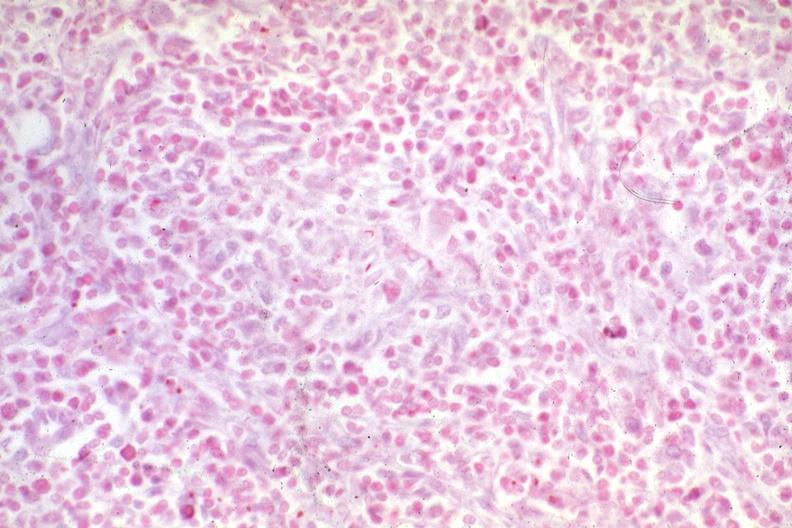what is present?
Answer the question using a single word or phrase. Lymph node 